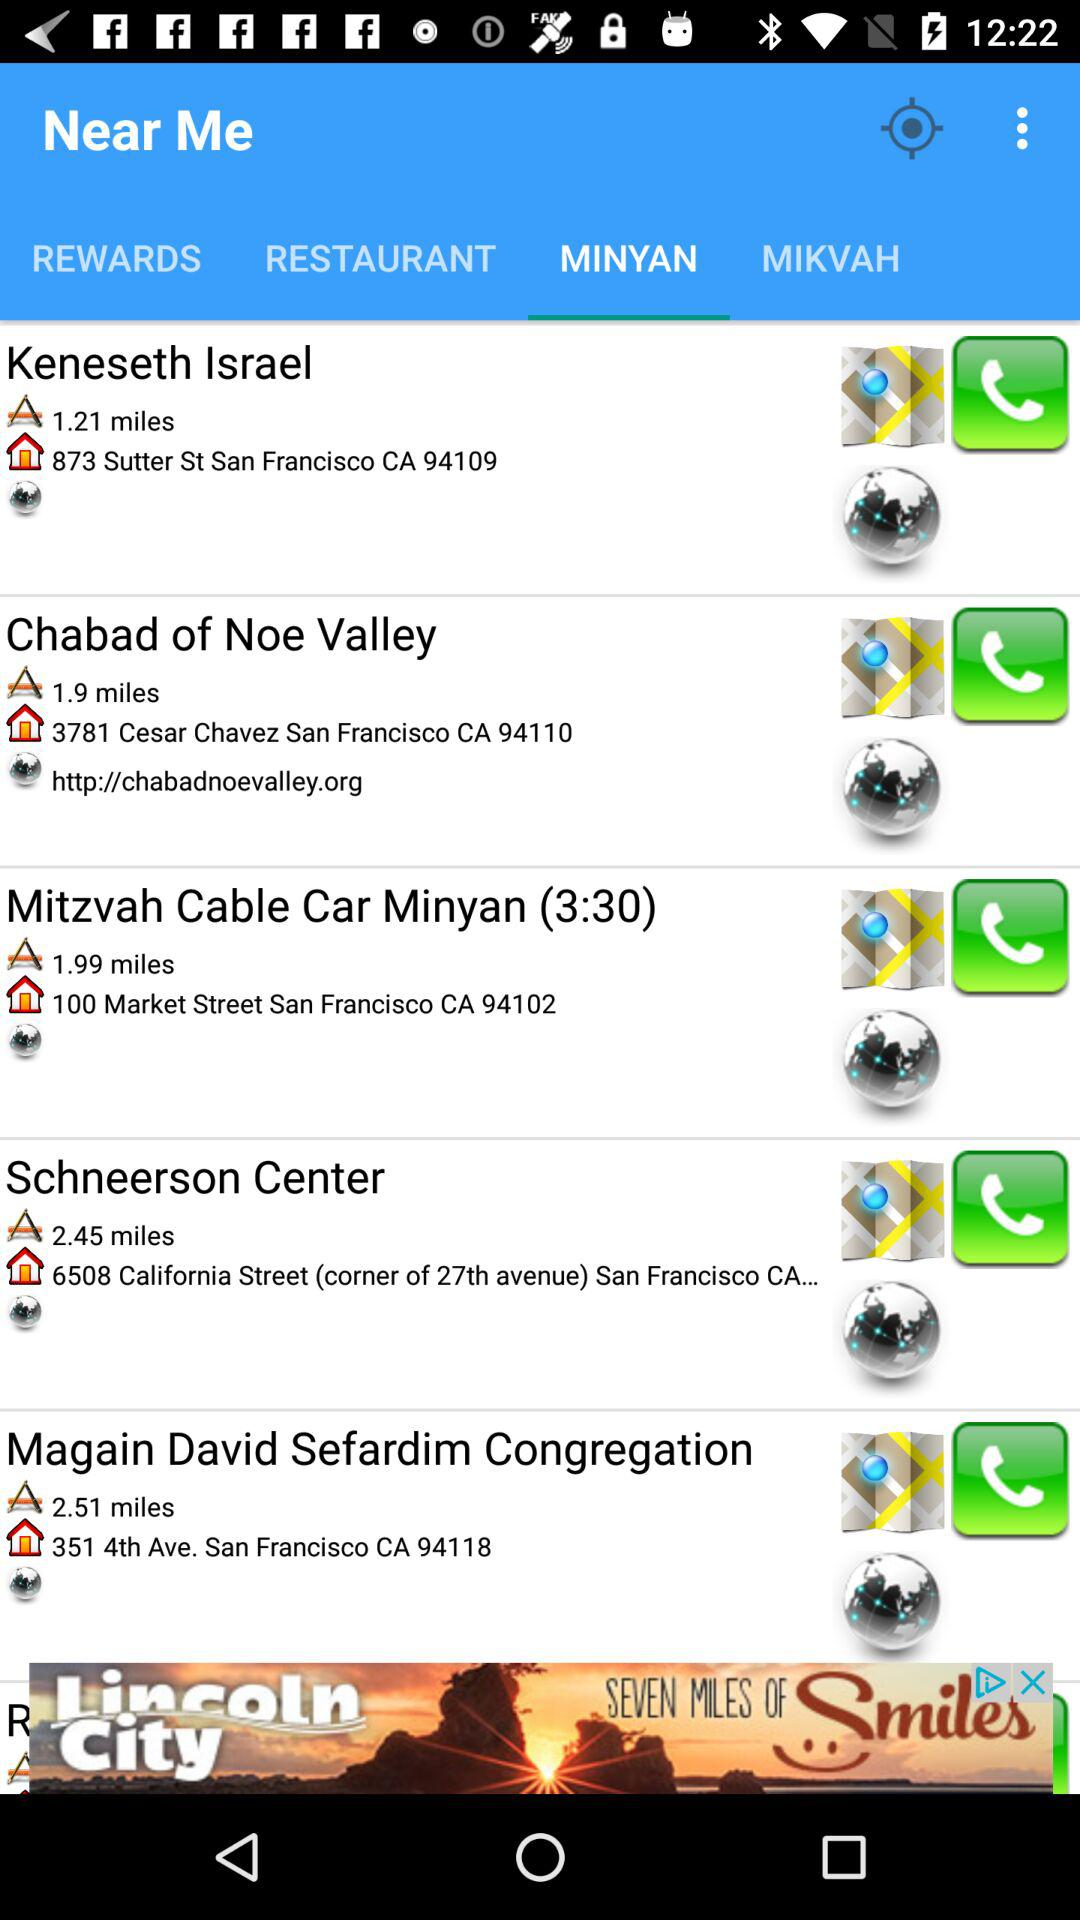How far is Keneseth Israel? Keneseth Israel is 1.21 miles away. 